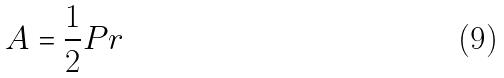Convert formula to latex. <formula><loc_0><loc_0><loc_500><loc_500>A = \frac { 1 } { 2 } P r</formula> 